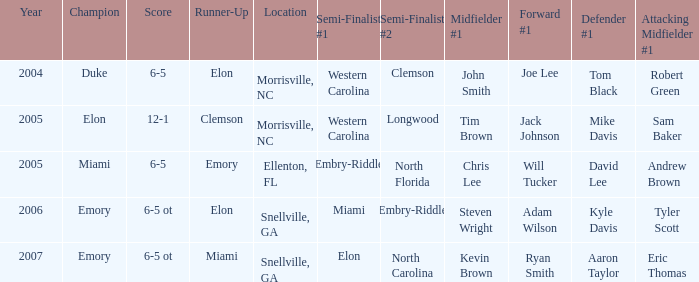Where was the final game played in 2007 Snellville, GA. 